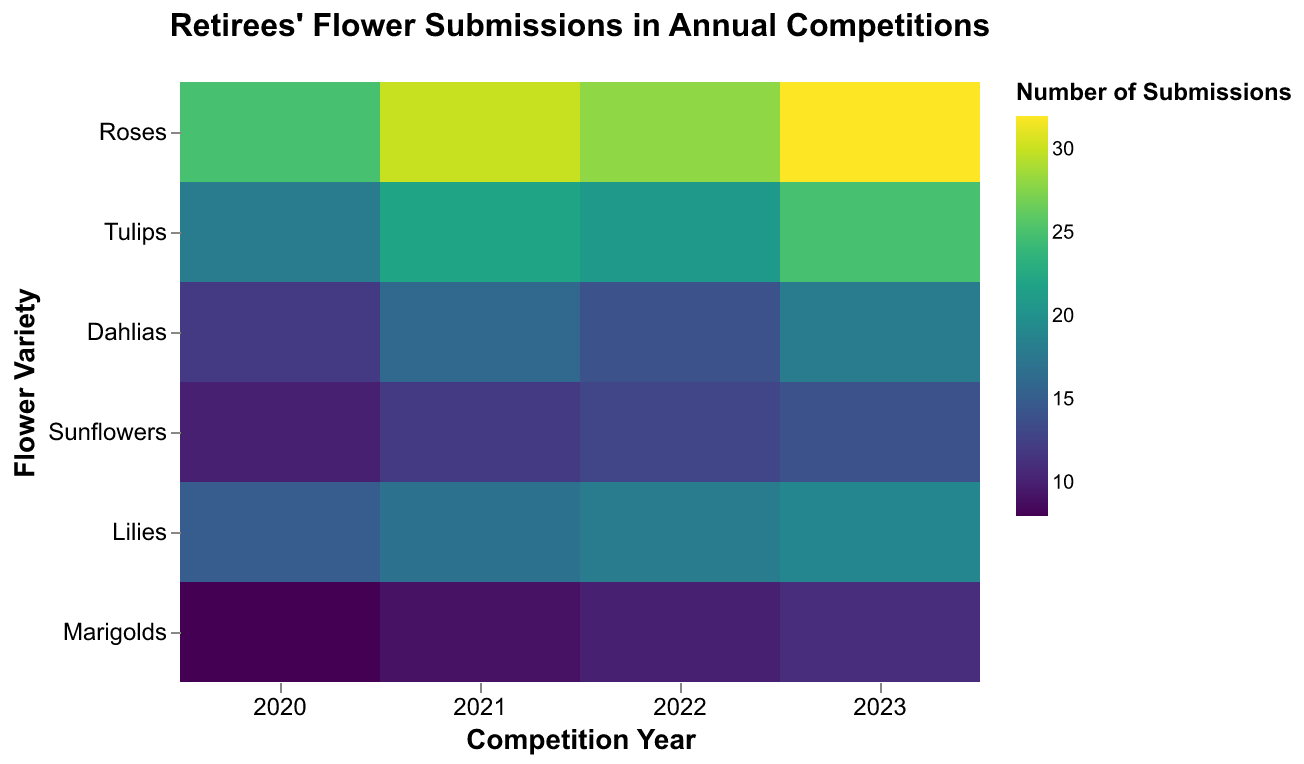What is the title of the figure? The title of the figure is displayed at the top and indicates the subject of the heatmap.
Answer: Retirees' Flower Submissions in Annual Competitions How many flower types are tracked in the heatmap? The vertical axis (y-axis) lists all the flower types. Count the number of unique flower types.
Answer: 6 Which flower type had the highest number of submissions in 2023? Look at the intersection of the year 2023 (x-axis) and the flower types (y-axis). Identify the highest value and its corresponding flower type.
Answer: Roses What color scheme is used in the heatmap? The color scheme is displayed in the color legend that represents the number of submissions.
Answer: Viridis What was the number of submissions for Lilies in 2021? Find the intersection of Lilies (y-axis) and 2021 (x-axis). The corresponding color or tooltip will show the number of submissions.
Answer: 17 Which flower type had the lowest number of submissions in 2020? Examine the year 2020 (x-axis) and compare the number of submissions of each flower type (y-axis). Identify the smallest value.
Answer: Marigolds How did the submissions for Dahlias change from 2020 to 2023? Compare the number of submissions for Dahlias in each year from 2020 to 2023. Note the changes year-by-year.
Answer: Increased from 12 to 18 Which year had the highest total number of flower submissions? Sum the number of submissions for each year and compare the totals.
Answer: 2023 